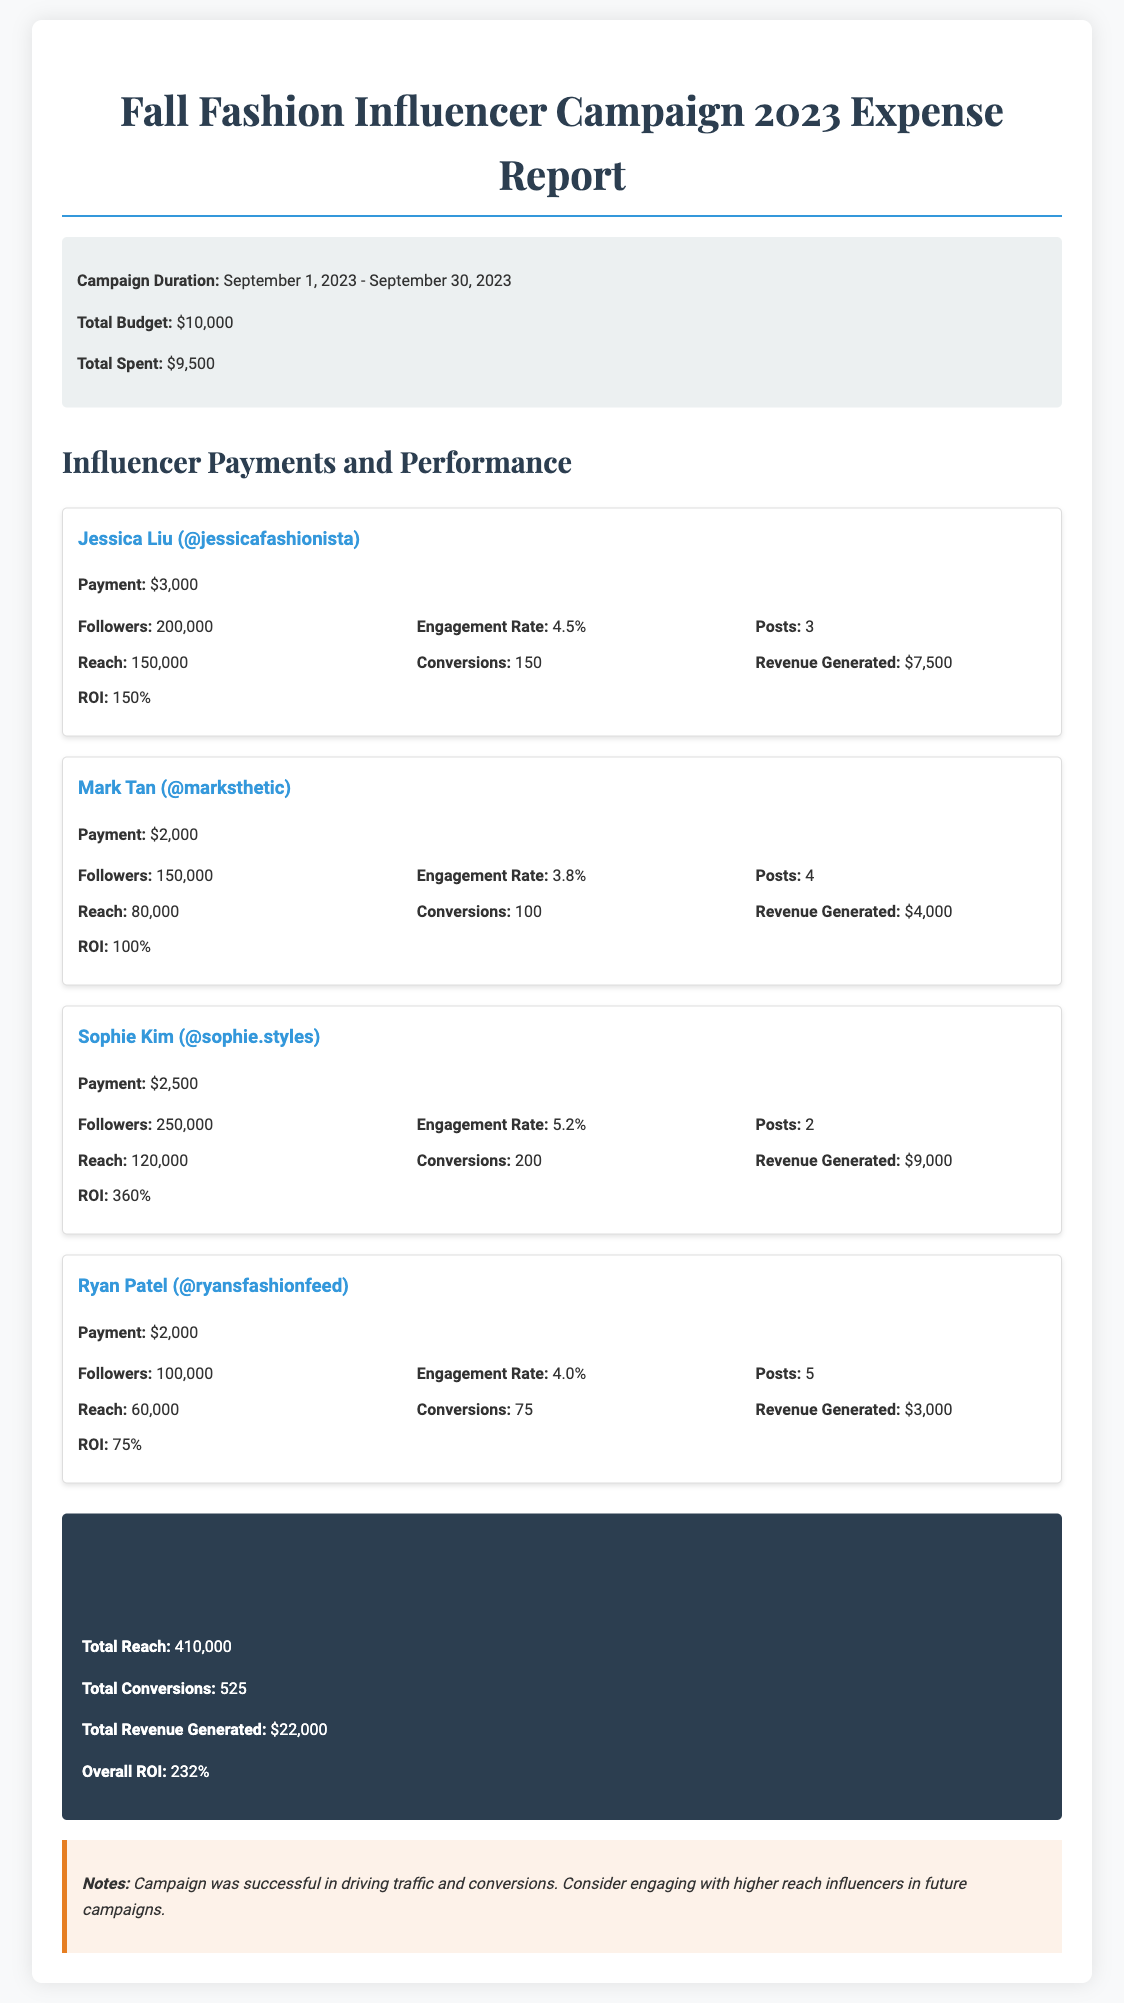What is the total budget for the campaign? The total budget is stated in the document's campaign info section.
Answer: $10,000 Who is the influencer with the highest ROI? The ROI for each influencer can be compared; Sophie Kim has the highest at 360%.
Answer: Sophie Kim What was the total spent during the campaign? The total spent is also found in the campaign info section of the document.
Answer: $9,500 How many conversions did Ryan Patel achieve? Ryan Patel's conversion count is directly mentioned in the influencer card for him.
Answer: 75 What is the campaign duration? The duration of the campaign is specified in the campaign information section.
Answer: September 1, 2023 - September 30, 2023 What is the overall ROI of the campaign? The overall ROI summarizes the return on investment for the entire campaign.
Answer: 232% Which influencer had the lowest payment? The payment amounts for each influencer allow for easy comparison.
Answer: Mark Tan What was the total reach of the campaign? The total reach is calculated and provided in the overall performance section.
Answer: 410,000 How many posts did Jessica Liu create? The number of posts by Jessica Liu is listed under her performance metrics.
Answer: 3 